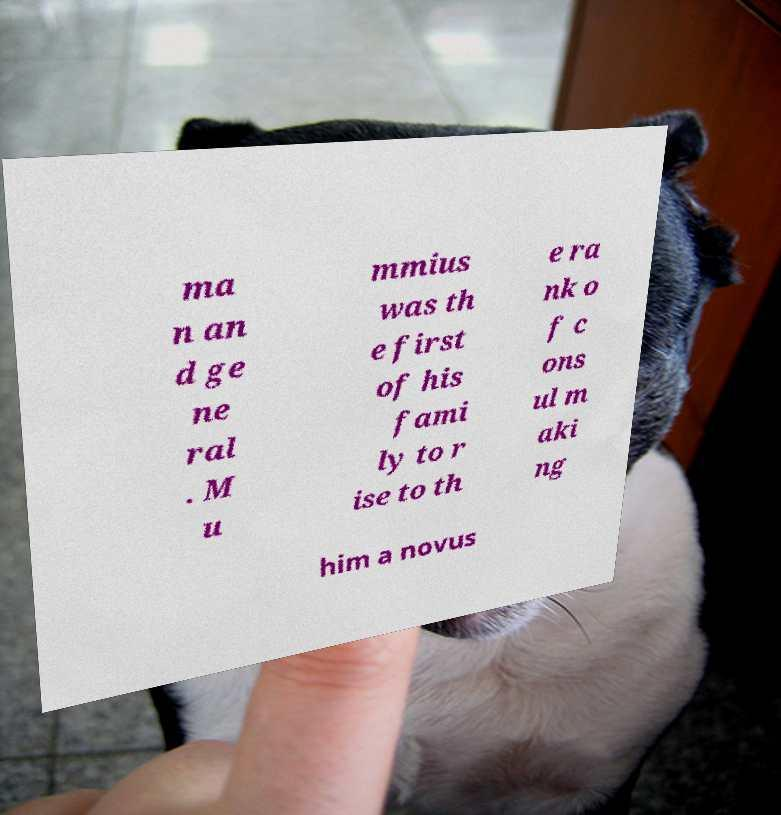There's text embedded in this image that I need extracted. Can you transcribe it verbatim? ma n an d ge ne ral . M u mmius was th e first of his fami ly to r ise to th e ra nk o f c ons ul m aki ng him a novus 